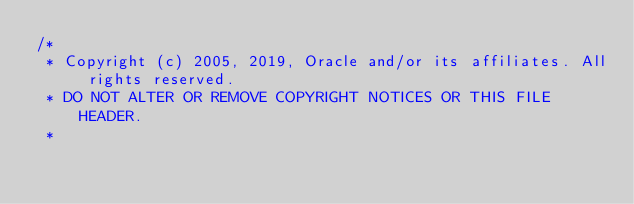Convert code to text. <code><loc_0><loc_0><loc_500><loc_500><_C_>/*
 * Copyright (c) 2005, 2019, Oracle and/or its affiliates. All rights reserved.
 * DO NOT ALTER OR REMOVE COPYRIGHT NOTICES OR THIS FILE HEADER.
 *</code> 